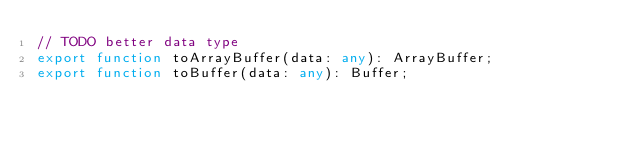Convert code to text. <code><loc_0><loc_0><loc_500><loc_500><_TypeScript_>// TODO better data type
export function toArrayBuffer(data: any): ArrayBuffer;
export function toBuffer(data: any): Buffer;
</code> 